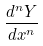<formula> <loc_0><loc_0><loc_500><loc_500>\frac { d ^ { n } Y } { d x ^ { n } }</formula> 